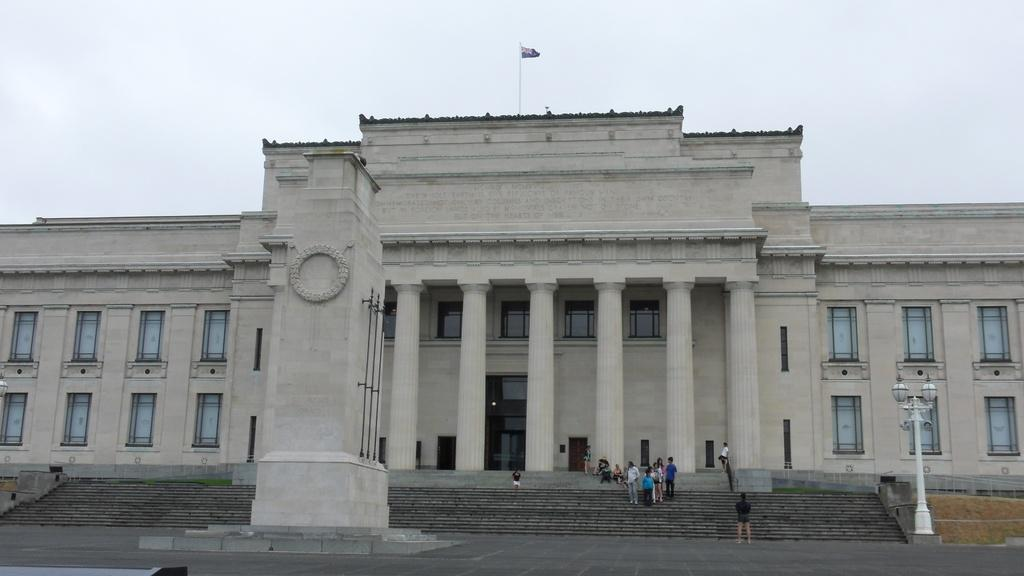How many people are in the image? There are people in the image, but the exact number is not specified. What type of surface is visible in the image? There is ground visible in the image. What architectural features can be seen in the image? There are pillars and poles in the image. What is attached to the poles in the image? There is a flag attached to the poles in the image. What can be used to provide illumination in the image? There are lights in the image. What type of structure is present in the image? There is a building in the image. What type of vegetation is visible in the image? There is grass in the image. What can be seen in the windows of the building? The windows in the image suggest that there may be rooms or spaces inside the building, but their contents are not visible. What is visible in the background of the image? The sky is visible in the background of the image. How do the people in the image adjust their behavior to accommodate the touch of the grass? There is no mention of the people interacting with the grass or adjusting their behavior in the image. 